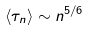Convert formula to latex. <formula><loc_0><loc_0><loc_500><loc_500>\left \langle \tau _ { n } \right \rangle \sim n ^ { 5 / 6 }</formula> 